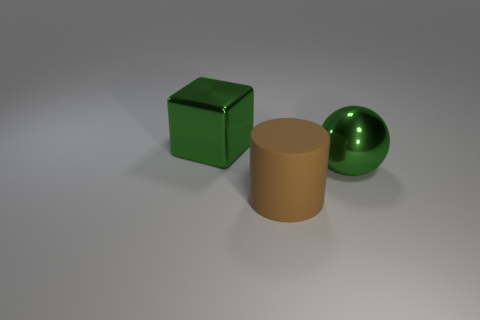Do the big metal object that is on the right side of the large brown rubber thing and the matte thing have the same shape?
Offer a terse response. No. Are any spheres visible?
Your response must be concise. Yes. The thing behind the shiny thing that is in front of the green metallic thing that is left of the big brown rubber thing is what color?
Keep it short and to the point. Green. Are there an equal number of large green blocks that are right of the big metallic sphere and large things behind the large cylinder?
Your answer should be very brief. No. There is a matte object that is the same size as the green ball; what is its shape?
Ensure brevity in your answer.  Cylinder. Are there any large metallic things that have the same color as the block?
Your response must be concise. Yes. There is a big thing that is behind the large metal sphere; what shape is it?
Provide a short and direct response. Cube. What is the color of the big cylinder?
Provide a short and direct response. Brown. How many other big green balls have the same material as the large sphere?
Give a very brief answer. 0. There is a large metal sphere; how many shiny balls are to the left of it?
Offer a terse response. 0. 